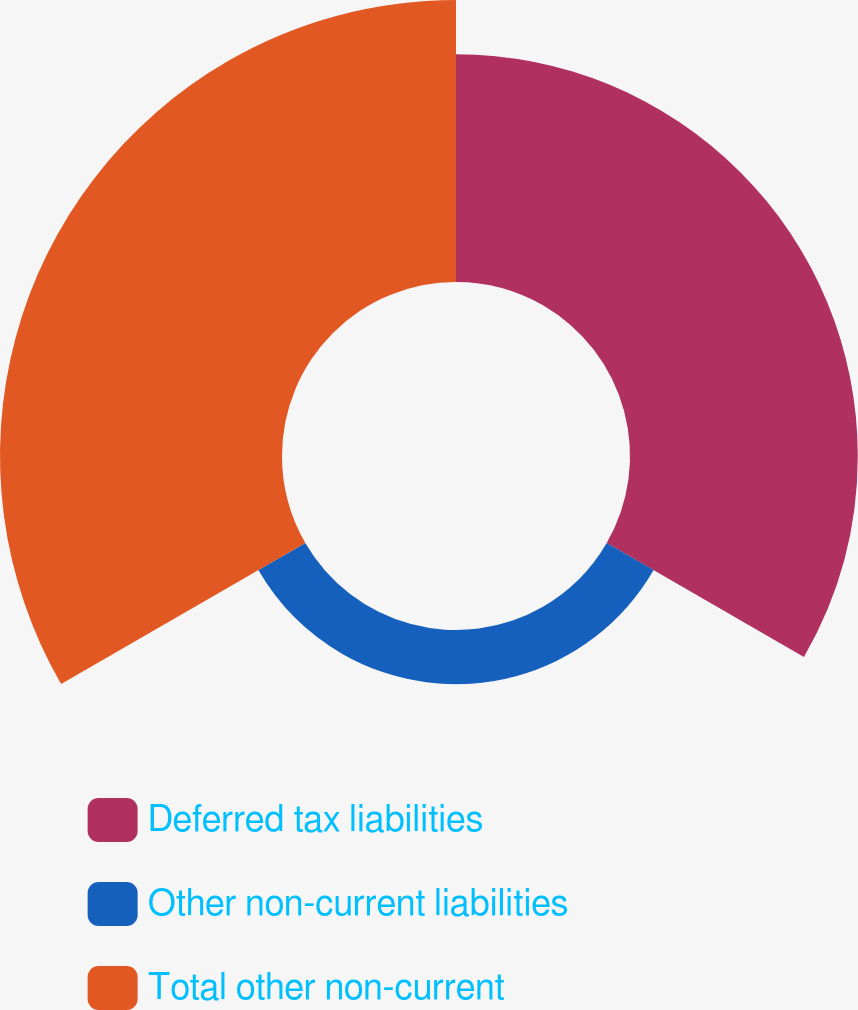Convert chart. <chart><loc_0><loc_0><loc_500><loc_500><pie_chart><fcel>Deferred tax liabilities<fcel>Other non-current liabilities<fcel>Total other non-current<nl><fcel>40.39%<fcel>9.61%<fcel>50.0%<nl></chart> 